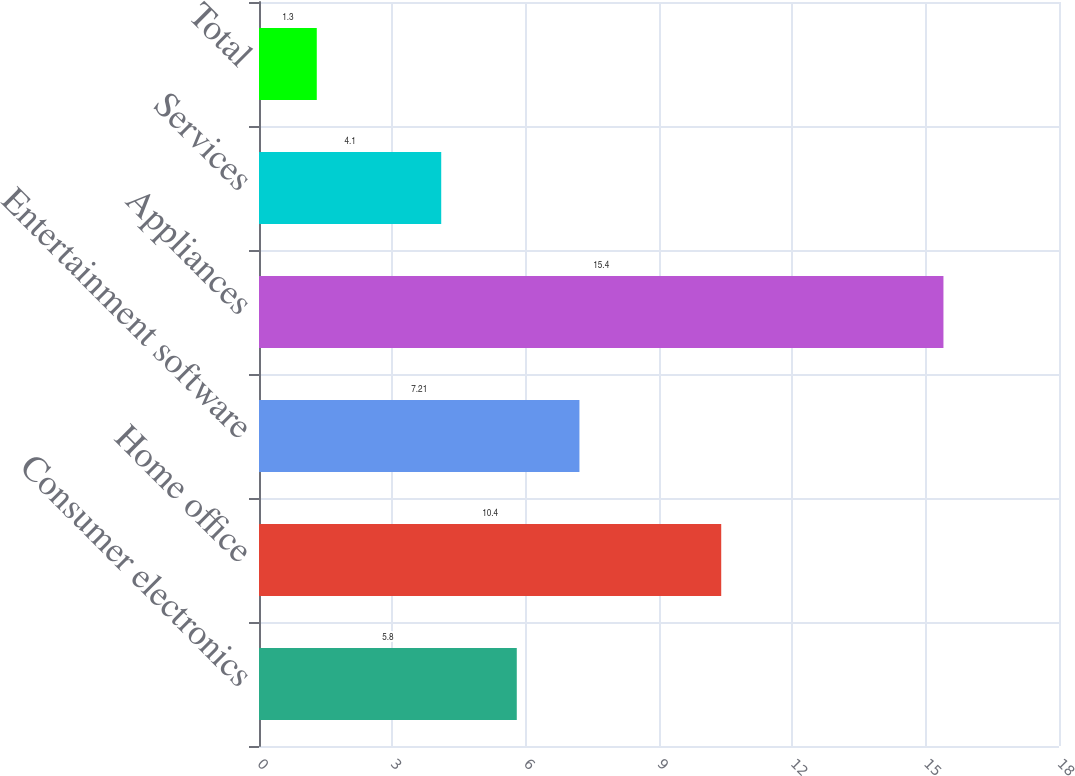Convert chart to OTSL. <chart><loc_0><loc_0><loc_500><loc_500><bar_chart><fcel>Consumer electronics<fcel>Home office<fcel>Entertainment software<fcel>Appliances<fcel>Services<fcel>Total<nl><fcel>5.8<fcel>10.4<fcel>7.21<fcel>15.4<fcel>4.1<fcel>1.3<nl></chart> 